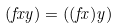<formula> <loc_0><loc_0><loc_500><loc_500>( f x y ) = ( ( f x ) y )</formula> 